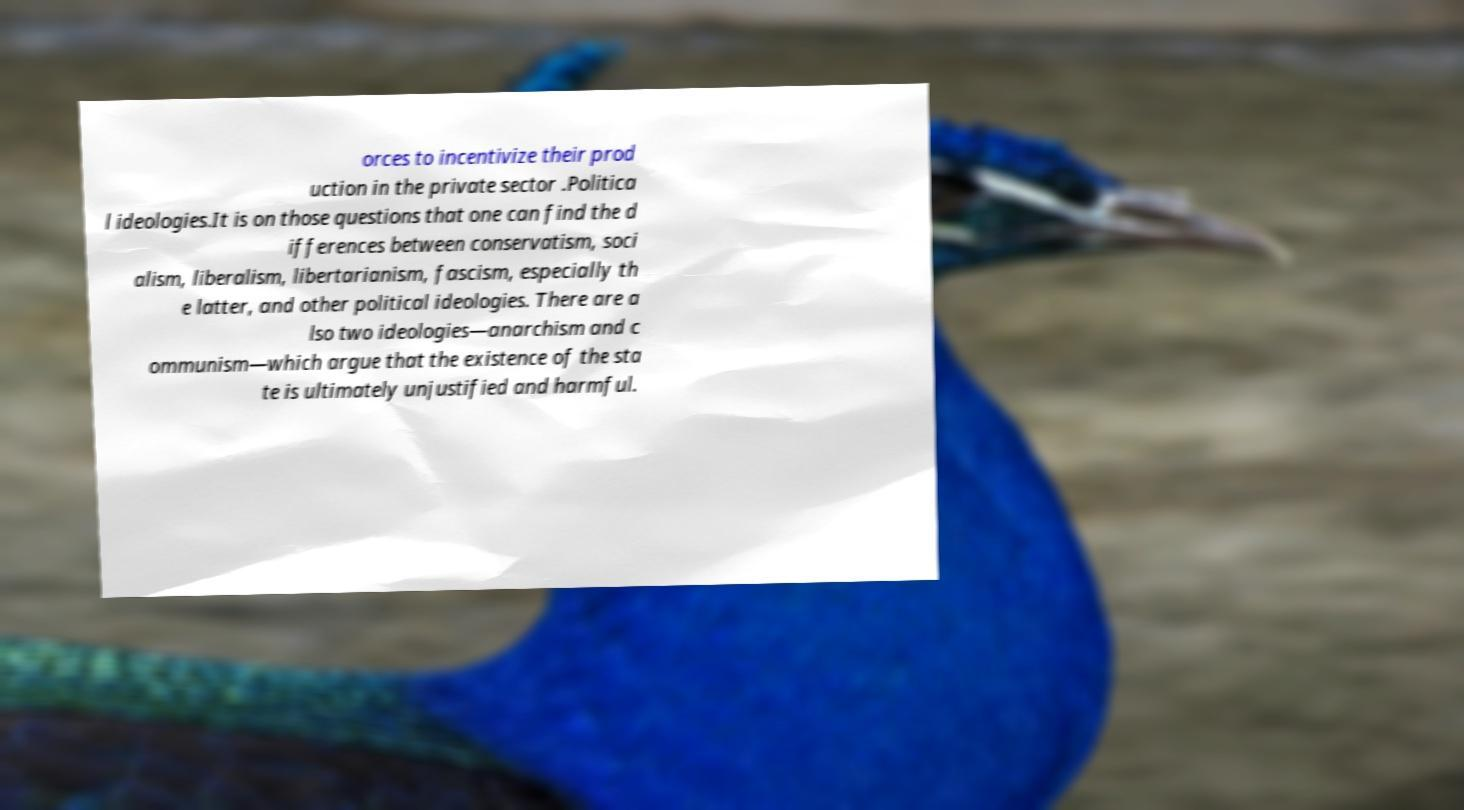Can you accurately transcribe the text from the provided image for me? orces to incentivize their prod uction in the private sector .Politica l ideologies.It is on those questions that one can find the d ifferences between conservatism, soci alism, liberalism, libertarianism, fascism, especially th e latter, and other political ideologies. There are a lso two ideologies—anarchism and c ommunism—which argue that the existence of the sta te is ultimately unjustified and harmful. 